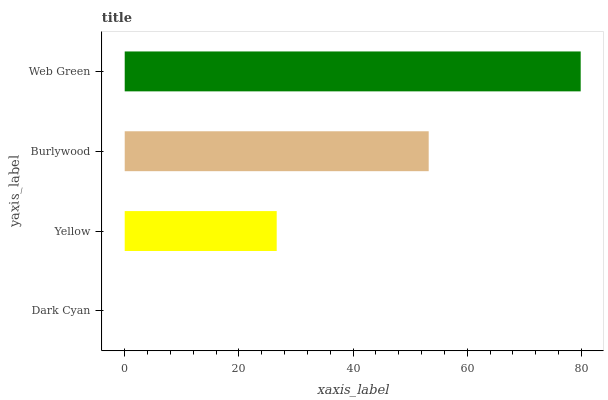Is Dark Cyan the minimum?
Answer yes or no. Yes. Is Web Green the maximum?
Answer yes or no. Yes. Is Yellow the minimum?
Answer yes or no. No. Is Yellow the maximum?
Answer yes or no. No. Is Yellow greater than Dark Cyan?
Answer yes or no. Yes. Is Dark Cyan less than Yellow?
Answer yes or no. Yes. Is Dark Cyan greater than Yellow?
Answer yes or no. No. Is Yellow less than Dark Cyan?
Answer yes or no. No. Is Burlywood the high median?
Answer yes or no. Yes. Is Yellow the low median?
Answer yes or no. Yes. Is Yellow the high median?
Answer yes or no. No. Is Burlywood the low median?
Answer yes or no. No. 